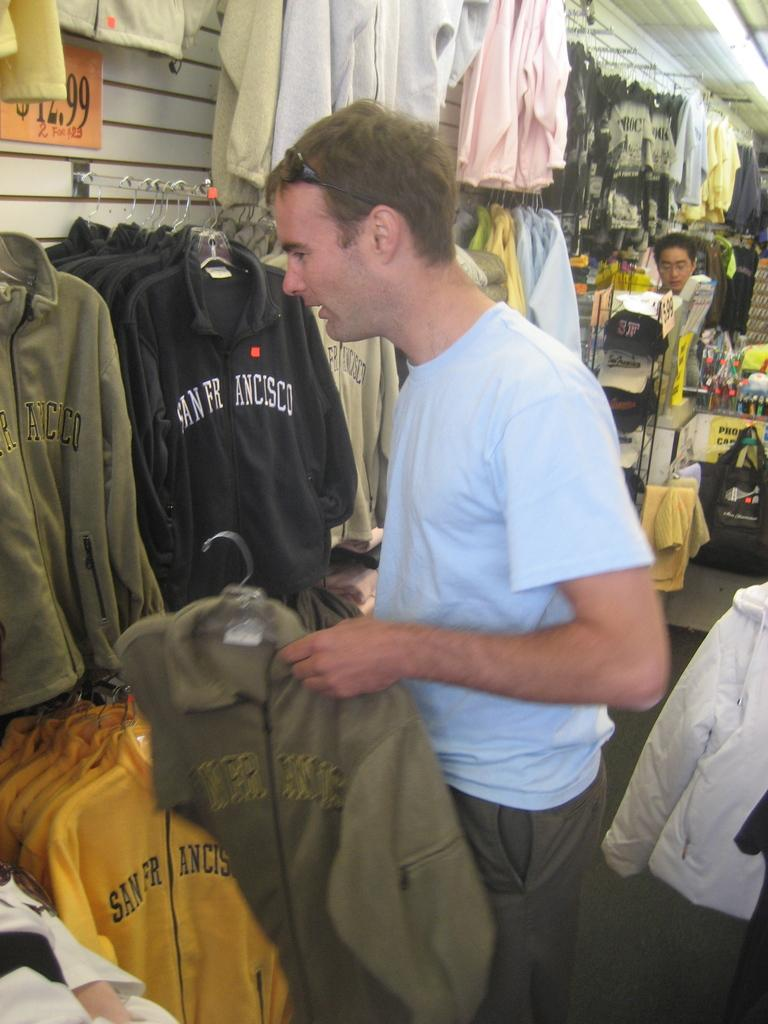<image>
Offer a succinct explanation of the picture presented. A man, possibly a tourist, looking through hooded sweatshirts with "San Francisco" embroidered on them. 